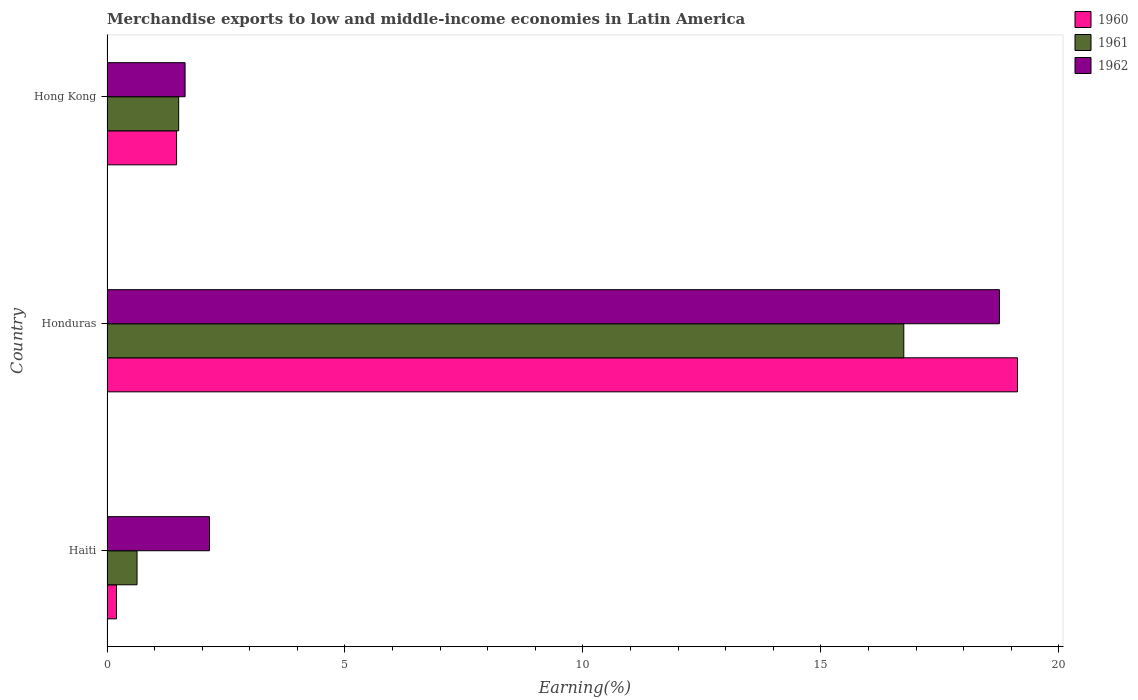How many bars are there on the 3rd tick from the top?
Offer a terse response. 3. How many bars are there on the 3rd tick from the bottom?
Provide a succinct answer. 3. What is the label of the 3rd group of bars from the top?
Give a very brief answer. Haiti. In how many cases, is the number of bars for a given country not equal to the number of legend labels?
Your response must be concise. 0. What is the percentage of amount earned from merchandise exports in 1962 in Hong Kong?
Provide a short and direct response. 1.64. Across all countries, what is the maximum percentage of amount earned from merchandise exports in 1962?
Give a very brief answer. 18.75. Across all countries, what is the minimum percentage of amount earned from merchandise exports in 1960?
Your response must be concise. 0.2. In which country was the percentage of amount earned from merchandise exports in 1961 maximum?
Your response must be concise. Honduras. In which country was the percentage of amount earned from merchandise exports in 1961 minimum?
Make the answer very short. Haiti. What is the total percentage of amount earned from merchandise exports in 1960 in the graph?
Keep it short and to the point. 20.79. What is the difference between the percentage of amount earned from merchandise exports in 1960 in Haiti and that in Hong Kong?
Your answer should be very brief. -1.26. What is the difference between the percentage of amount earned from merchandise exports in 1961 in Hong Kong and the percentage of amount earned from merchandise exports in 1962 in Haiti?
Your response must be concise. -0.65. What is the average percentage of amount earned from merchandise exports in 1962 per country?
Your answer should be compact. 7.51. What is the difference between the percentage of amount earned from merchandise exports in 1962 and percentage of amount earned from merchandise exports in 1960 in Haiti?
Provide a short and direct response. 1.95. What is the ratio of the percentage of amount earned from merchandise exports in 1962 in Honduras to that in Hong Kong?
Offer a very short reply. 11.43. What is the difference between the highest and the second highest percentage of amount earned from merchandise exports in 1960?
Provide a short and direct response. 17.67. What is the difference between the highest and the lowest percentage of amount earned from merchandise exports in 1962?
Provide a short and direct response. 17.11. In how many countries, is the percentage of amount earned from merchandise exports in 1962 greater than the average percentage of amount earned from merchandise exports in 1962 taken over all countries?
Keep it short and to the point. 1. Is the sum of the percentage of amount earned from merchandise exports in 1961 in Haiti and Honduras greater than the maximum percentage of amount earned from merchandise exports in 1962 across all countries?
Offer a terse response. No. What does the 2nd bar from the bottom in Hong Kong represents?
Provide a short and direct response. 1961. Is it the case that in every country, the sum of the percentage of amount earned from merchandise exports in 1960 and percentage of amount earned from merchandise exports in 1962 is greater than the percentage of amount earned from merchandise exports in 1961?
Keep it short and to the point. Yes. How many bars are there?
Your response must be concise. 9. Are the values on the major ticks of X-axis written in scientific E-notation?
Offer a very short reply. No. Does the graph contain any zero values?
Provide a short and direct response. No. Does the graph contain grids?
Make the answer very short. No. Where does the legend appear in the graph?
Keep it short and to the point. Top right. What is the title of the graph?
Provide a short and direct response. Merchandise exports to low and middle-income economies in Latin America. What is the label or title of the X-axis?
Provide a short and direct response. Earning(%). What is the label or title of the Y-axis?
Your response must be concise. Country. What is the Earning(%) in 1960 in Haiti?
Keep it short and to the point. 0.2. What is the Earning(%) of 1961 in Haiti?
Give a very brief answer. 0.63. What is the Earning(%) in 1962 in Haiti?
Your answer should be compact. 2.15. What is the Earning(%) in 1960 in Honduras?
Offer a terse response. 19.13. What is the Earning(%) in 1961 in Honduras?
Your answer should be compact. 16.74. What is the Earning(%) in 1962 in Honduras?
Make the answer very short. 18.75. What is the Earning(%) of 1960 in Hong Kong?
Provide a short and direct response. 1.46. What is the Earning(%) of 1961 in Hong Kong?
Offer a very short reply. 1.51. What is the Earning(%) of 1962 in Hong Kong?
Provide a succinct answer. 1.64. Across all countries, what is the maximum Earning(%) in 1960?
Provide a succinct answer. 19.13. Across all countries, what is the maximum Earning(%) of 1961?
Ensure brevity in your answer.  16.74. Across all countries, what is the maximum Earning(%) in 1962?
Provide a short and direct response. 18.75. Across all countries, what is the minimum Earning(%) of 1960?
Make the answer very short. 0.2. Across all countries, what is the minimum Earning(%) of 1961?
Provide a succinct answer. 0.63. Across all countries, what is the minimum Earning(%) in 1962?
Ensure brevity in your answer.  1.64. What is the total Earning(%) in 1960 in the graph?
Provide a short and direct response. 20.79. What is the total Earning(%) of 1961 in the graph?
Provide a succinct answer. 18.88. What is the total Earning(%) in 1962 in the graph?
Make the answer very short. 22.54. What is the difference between the Earning(%) in 1960 in Haiti and that in Honduras?
Your answer should be very brief. -18.93. What is the difference between the Earning(%) in 1961 in Haiti and that in Honduras?
Your response must be concise. -16.11. What is the difference between the Earning(%) in 1962 in Haiti and that in Honduras?
Your answer should be very brief. -16.6. What is the difference between the Earning(%) of 1960 in Haiti and that in Hong Kong?
Offer a very short reply. -1.26. What is the difference between the Earning(%) in 1961 in Haiti and that in Hong Kong?
Your answer should be very brief. -0.87. What is the difference between the Earning(%) of 1962 in Haiti and that in Hong Kong?
Keep it short and to the point. 0.51. What is the difference between the Earning(%) in 1960 in Honduras and that in Hong Kong?
Offer a very short reply. 17.67. What is the difference between the Earning(%) in 1961 in Honduras and that in Hong Kong?
Your answer should be very brief. 15.24. What is the difference between the Earning(%) in 1962 in Honduras and that in Hong Kong?
Provide a succinct answer. 17.11. What is the difference between the Earning(%) in 1960 in Haiti and the Earning(%) in 1961 in Honduras?
Provide a succinct answer. -16.54. What is the difference between the Earning(%) of 1960 in Haiti and the Earning(%) of 1962 in Honduras?
Make the answer very short. -18.55. What is the difference between the Earning(%) of 1961 in Haiti and the Earning(%) of 1962 in Honduras?
Your answer should be compact. -18.12. What is the difference between the Earning(%) in 1960 in Haiti and the Earning(%) in 1961 in Hong Kong?
Give a very brief answer. -1.31. What is the difference between the Earning(%) in 1960 in Haiti and the Earning(%) in 1962 in Hong Kong?
Offer a terse response. -1.44. What is the difference between the Earning(%) of 1961 in Haiti and the Earning(%) of 1962 in Hong Kong?
Make the answer very short. -1.01. What is the difference between the Earning(%) in 1960 in Honduras and the Earning(%) in 1961 in Hong Kong?
Offer a very short reply. 17.62. What is the difference between the Earning(%) in 1960 in Honduras and the Earning(%) in 1962 in Hong Kong?
Offer a terse response. 17.49. What is the difference between the Earning(%) of 1961 in Honduras and the Earning(%) of 1962 in Hong Kong?
Offer a very short reply. 15.1. What is the average Earning(%) in 1960 per country?
Keep it short and to the point. 6.93. What is the average Earning(%) in 1961 per country?
Your answer should be compact. 6.29. What is the average Earning(%) in 1962 per country?
Make the answer very short. 7.51. What is the difference between the Earning(%) of 1960 and Earning(%) of 1961 in Haiti?
Your answer should be very brief. -0.43. What is the difference between the Earning(%) in 1960 and Earning(%) in 1962 in Haiti?
Make the answer very short. -1.95. What is the difference between the Earning(%) in 1961 and Earning(%) in 1962 in Haiti?
Your answer should be very brief. -1.52. What is the difference between the Earning(%) of 1960 and Earning(%) of 1961 in Honduras?
Your response must be concise. 2.39. What is the difference between the Earning(%) in 1960 and Earning(%) in 1962 in Honduras?
Your response must be concise. 0.38. What is the difference between the Earning(%) in 1961 and Earning(%) in 1962 in Honduras?
Provide a succinct answer. -2.01. What is the difference between the Earning(%) of 1960 and Earning(%) of 1961 in Hong Kong?
Your answer should be compact. -0.04. What is the difference between the Earning(%) of 1960 and Earning(%) of 1962 in Hong Kong?
Your answer should be compact. -0.18. What is the difference between the Earning(%) in 1961 and Earning(%) in 1962 in Hong Kong?
Keep it short and to the point. -0.13. What is the ratio of the Earning(%) in 1960 in Haiti to that in Honduras?
Provide a short and direct response. 0.01. What is the ratio of the Earning(%) of 1961 in Haiti to that in Honduras?
Keep it short and to the point. 0.04. What is the ratio of the Earning(%) of 1962 in Haiti to that in Honduras?
Your answer should be very brief. 0.11. What is the ratio of the Earning(%) of 1960 in Haiti to that in Hong Kong?
Offer a terse response. 0.14. What is the ratio of the Earning(%) of 1961 in Haiti to that in Hong Kong?
Your response must be concise. 0.42. What is the ratio of the Earning(%) of 1962 in Haiti to that in Hong Kong?
Your answer should be very brief. 1.31. What is the ratio of the Earning(%) of 1960 in Honduras to that in Hong Kong?
Ensure brevity in your answer.  13.09. What is the ratio of the Earning(%) in 1961 in Honduras to that in Hong Kong?
Your answer should be compact. 11.12. What is the ratio of the Earning(%) of 1962 in Honduras to that in Hong Kong?
Give a very brief answer. 11.43. What is the difference between the highest and the second highest Earning(%) in 1960?
Give a very brief answer. 17.67. What is the difference between the highest and the second highest Earning(%) of 1961?
Provide a succinct answer. 15.24. What is the difference between the highest and the second highest Earning(%) in 1962?
Offer a terse response. 16.6. What is the difference between the highest and the lowest Earning(%) of 1960?
Keep it short and to the point. 18.93. What is the difference between the highest and the lowest Earning(%) in 1961?
Your response must be concise. 16.11. What is the difference between the highest and the lowest Earning(%) in 1962?
Provide a succinct answer. 17.11. 